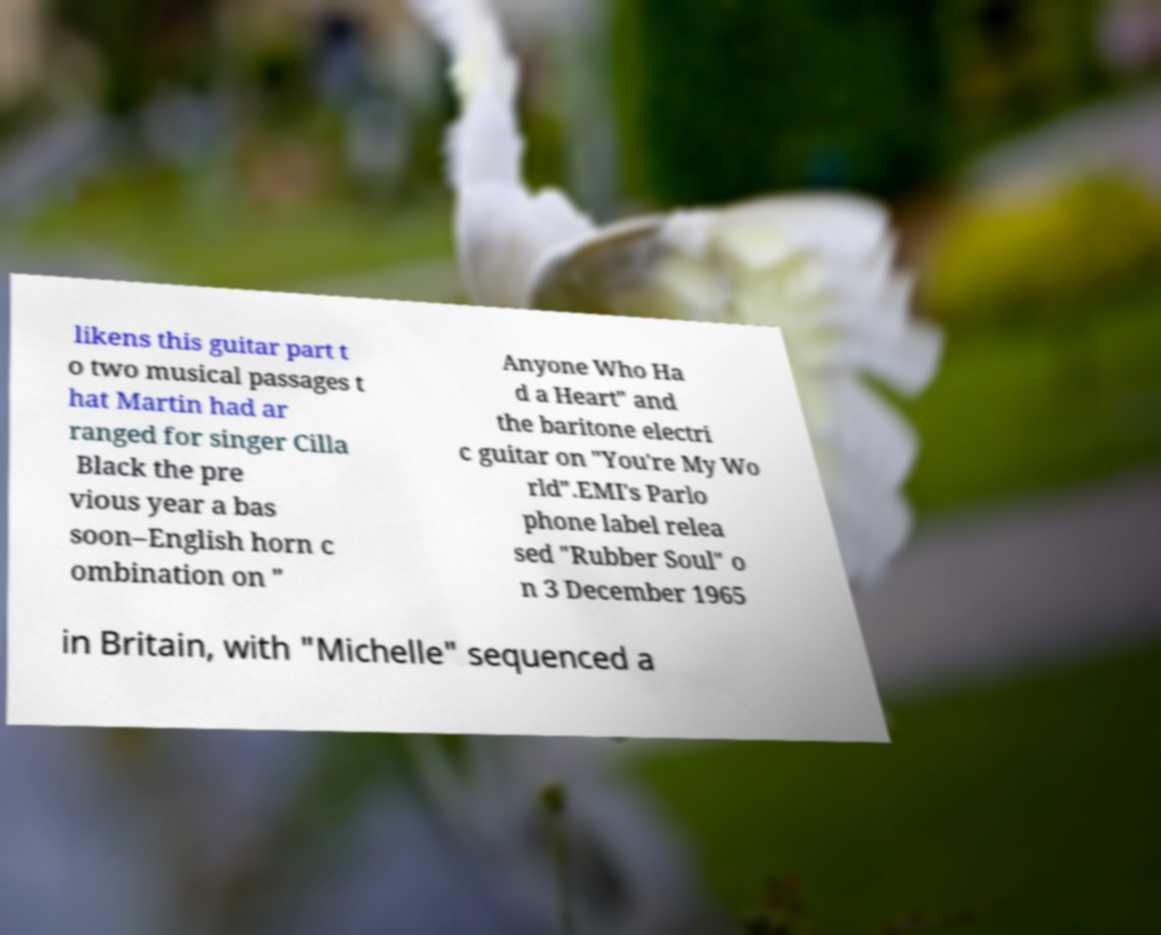Please read and relay the text visible in this image. What does it say? likens this guitar part t o two musical passages t hat Martin had ar ranged for singer Cilla Black the pre vious year a bas soon–English horn c ombination on " Anyone Who Ha d a Heart" and the baritone electri c guitar on "You're My Wo rld".EMI's Parlo phone label relea sed "Rubber Soul" o n 3 December 1965 in Britain, with "Michelle" sequenced a 